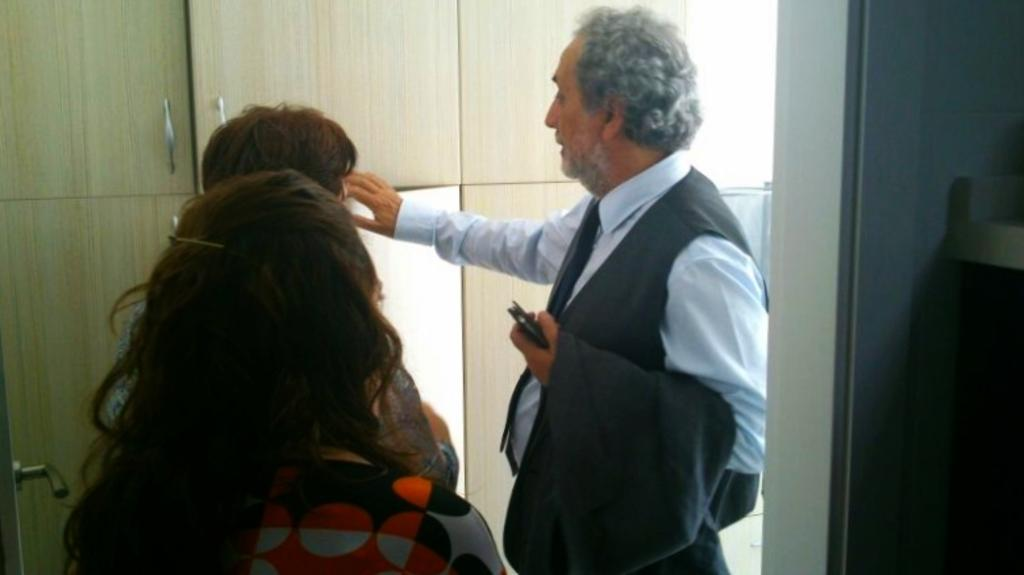How many people are in the image? There are three persons in the image. What is one of the persons holding? One of the persons is holding a cell phone. What type of furniture can be seen in the image? There are cupboards in the image. What is a prominent feature of the background in the image? There is a wall in the image. What type of soup is being prepared on the spot in the image? There is no soup or any indication of food preparation in the image. 